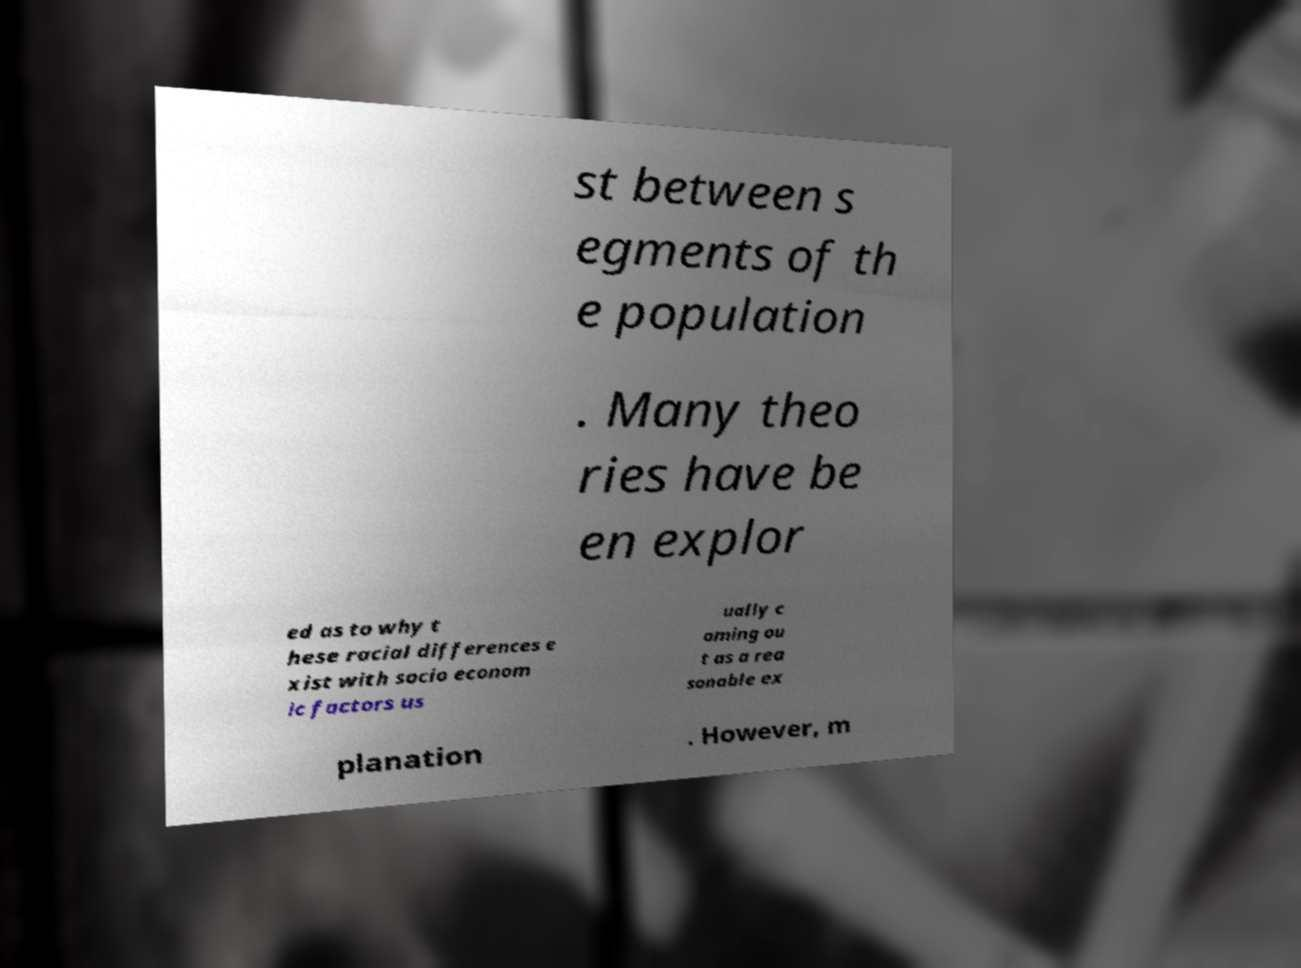Please identify and transcribe the text found in this image. st between s egments of th e population . Many theo ries have be en explor ed as to why t hese racial differences e xist with socio econom ic factors us ually c oming ou t as a rea sonable ex planation . However, m 